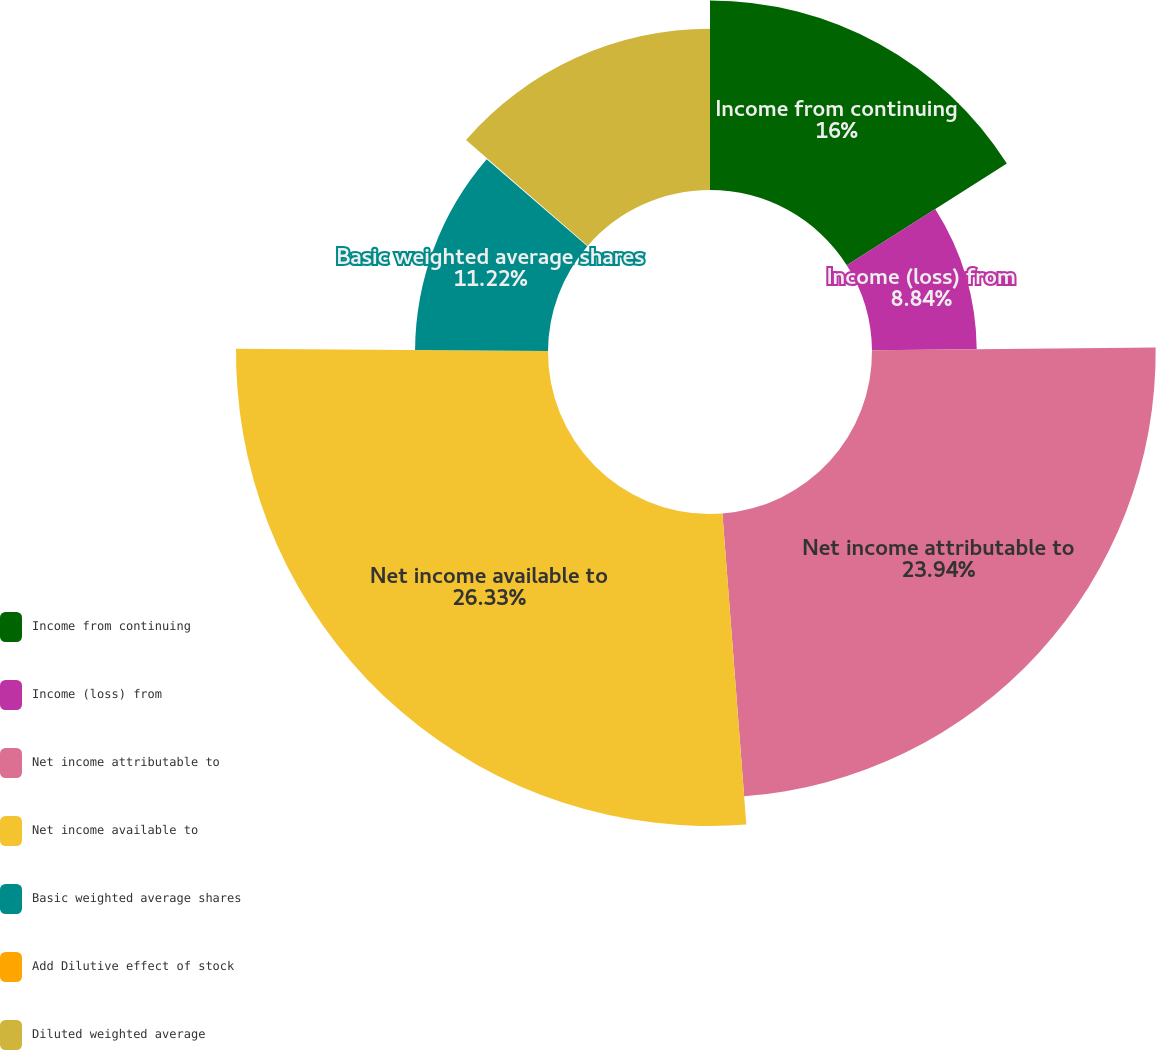<chart> <loc_0><loc_0><loc_500><loc_500><pie_chart><fcel>Income from continuing<fcel>Income (loss) from<fcel>Net income attributable to<fcel>Net income available to<fcel>Basic weighted average shares<fcel>Add Dilutive effect of stock<fcel>Diluted weighted average<nl><fcel>16.0%<fcel>8.84%<fcel>23.94%<fcel>26.33%<fcel>11.22%<fcel>0.06%<fcel>13.61%<nl></chart> 